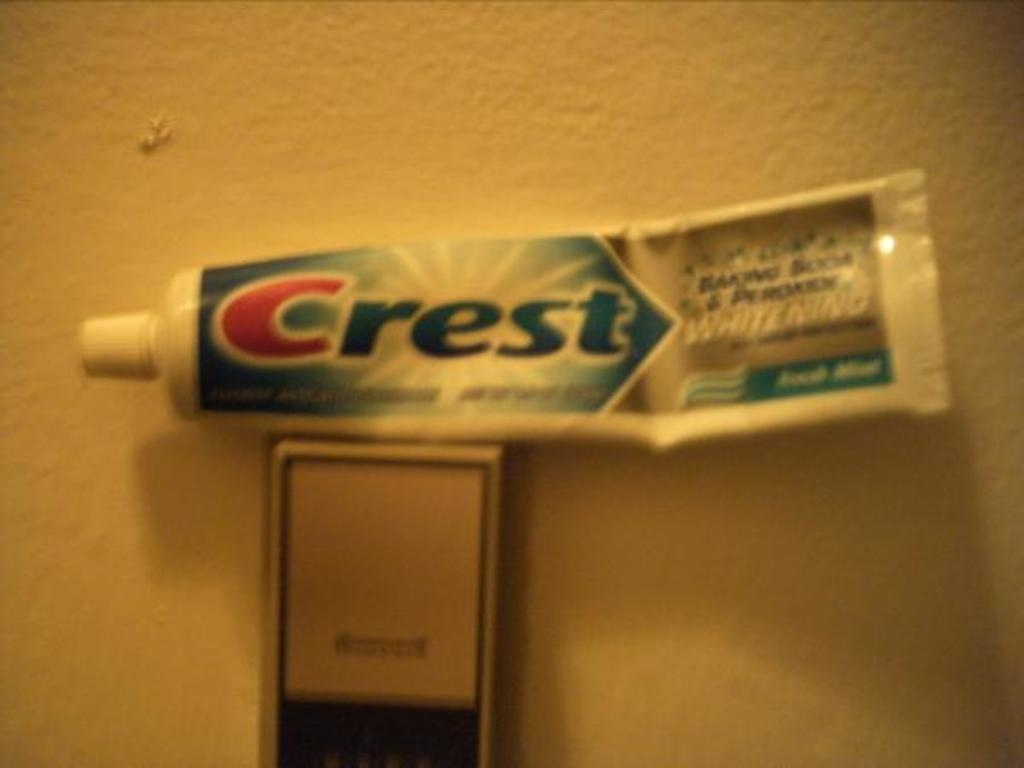Provide a one-sentence caption for the provided image. A tube of Crest fresh mint toothpaste is on top of a thermostat. 